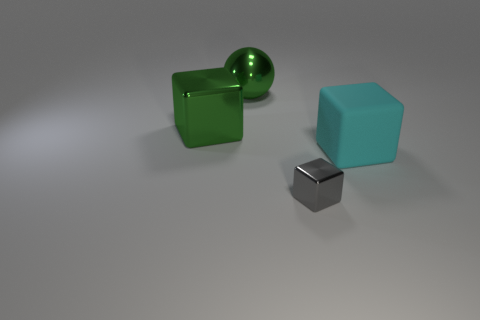The metallic block that is in front of the large cube that is on the right side of the metal block that is in front of the big cyan cube is what color? gray 